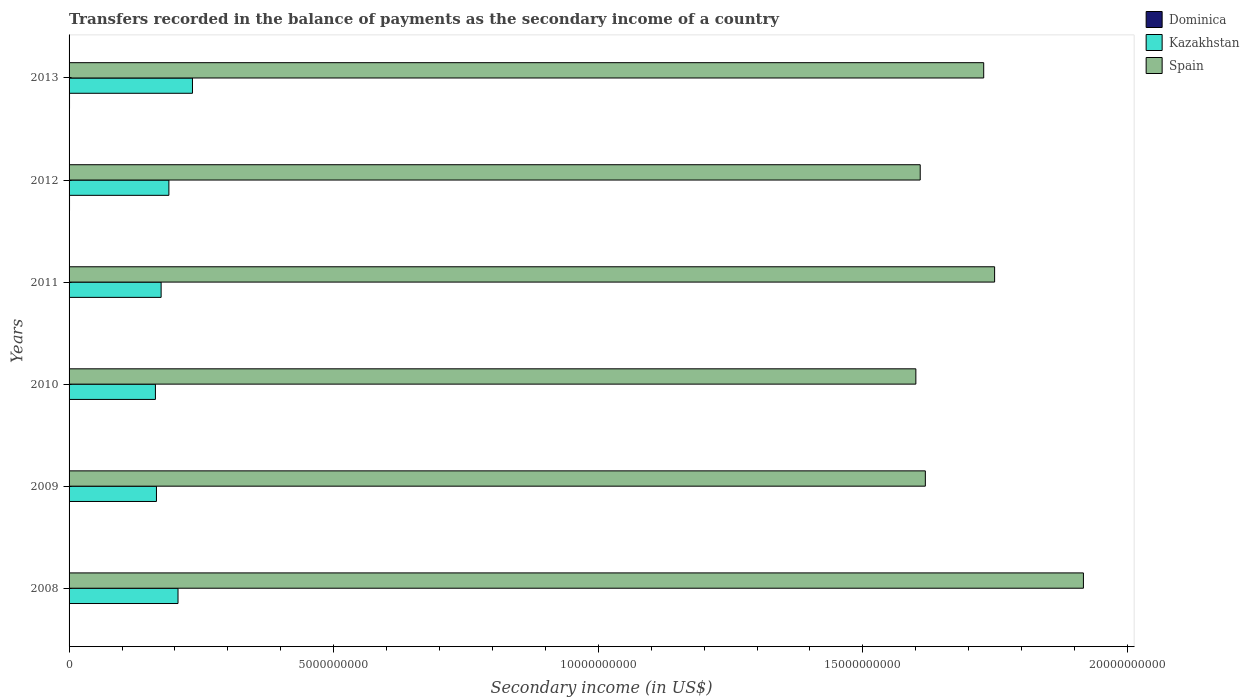How many different coloured bars are there?
Offer a very short reply. 3. What is the label of the 6th group of bars from the top?
Your answer should be compact. 2008. What is the secondary income of in Kazakhstan in 2008?
Ensure brevity in your answer.  2.06e+09. Across all years, what is the maximum secondary income of in Dominica?
Provide a short and direct response. 8.64e+06. Across all years, what is the minimum secondary income of in Kazakhstan?
Provide a short and direct response. 1.63e+09. What is the total secondary income of in Spain in the graph?
Offer a very short reply. 1.02e+11. What is the difference between the secondary income of in Dominica in 2011 and that in 2013?
Your answer should be compact. -2.50e+06. What is the difference between the secondary income of in Kazakhstan in 2010 and the secondary income of in Dominica in 2013?
Offer a very short reply. 1.62e+09. What is the average secondary income of in Spain per year?
Provide a succinct answer. 1.70e+1. In the year 2013, what is the difference between the secondary income of in Spain and secondary income of in Kazakhstan?
Give a very brief answer. 1.50e+1. In how many years, is the secondary income of in Dominica greater than 2000000000 US$?
Provide a succinct answer. 0. What is the ratio of the secondary income of in Spain in 2008 to that in 2009?
Ensure brevity in your answer.  1.18. What is the difference between the highest and the second highest secondary income of in Kazakhstan?
Make the answer very short. 2.73e+08. What is the difference between the highest and the lowest secondary income of in Dominica?
Ensure brevity in your answer.  3.87e+06. In how many years, is the secondary income of in Dominica greater than the average secondary income of in Dominica taken over all years?
Ensure brevity in your answer.  2. What does the 3rd bar from the top in 2013 represents?
Provide a succinct answer. Dominica. What does the 3rd bar from the bottom in 2012 represents?
Your response must be concise. Spain. How many bars are there?
Your answer should be compact. 18. Are the values on the major ticks of X-axis written in scientific E-notation?
Your response must be concise. No. Does the graph contain any zero values?
Offer a very short reply. No. Where does the legend appear in the graph?
Provide a succinct answer. Top right. How many legend labels are there?
Provide a short and direct response. 3. How are the legend labels stacked?
Your answer should be very brief. Vertical. What is the title of the graph?
Offer a very short reply. Transfers recorded in the balance of payments as the secondary income of a country. Does "Serbia" appear as one of the legend labels in the graph?
Your answer should be very brief. No. What is the label or title of the X-axis?
Keep it short and to the point. Secondary income (in US$). What is the Secondary income (in US$) in Dominica in 2008?
Keep it short and to the point. 4.96e+06. What is the Secondary income (in US$) of Kazakhstan in 2008?
Your answer should be very brief. 2.06e+09. What is the Secondary income (in US$) of Spain in 2008?
Give a very brief answer. 1.92e+1. What is the Secondary income (in US$) of Dominica in 2009?
Keep it short and to the point. 4.77e+06. What is the Secondary income (in US$) of Kazakhstan in 2009?
Ensure brevity in your answer.  1.65e+09. What is the Secondary income (in US$) in Spain in 2009?
Offer a terse response. 1.62e+1. What is the Secondary income (in US$) of Dominica in 2010?
Your answer should be compact. 4.85e+06. What is the Secondary income (in US$) in Kazakhstan in 2010?
Your response must be concise. 1.63e+09. What is the Secondary income (in US$) in Spain in 2010?
Offer a terse response. 1.60e+1. What is the Secondary income (in US$) in Dominica in 2011?
Your answer should be compact. 6.14e+06. What is the Secondary income (in US$) of Kazakhstan in 2011?
Provide a succinct answer. 1.74e+09. What is the Secondary income (in US$) of Spain in 2011?
Give a very brief answer. 1.75e+1. What is the Secondary income (in US$) in Dominica in 2012?
Give a very brief answer. 8.56e+06. What is the Secondary income (in US$) of Kazakhstan in 2012?
Ensure brevity in your answer.  1.89e+09. What is the Secondary income (in US$) of Spain in 2012?
Your answer should be compact. 1.61e+1. What is the Secondary income (in US$) in Dominica in 2013?
Provide a short and direct response. 8.64e+06. What is the Secondary income (in US$) in Kazakhstan in 2013?
Your answer should be very brief. 2.33e+09. What is the Secondary income (in US$) in Spain in 2013?
Provide a succinct answer. 1.73e+1. Across all years, what is the maximum Secondary income (in US$) in Dominica?
Provide a succinct answer. 8.64e+06. Across all years, what is the maximum Secondary income (in US$) of Kazakhstan?
Ensure brevity in your answer.  2.33e+09. Across all years, what is the maximum Secondary income (in US$) of Spain?
Your response must be concise. 1.92e+1. Across all years, what is the minimum Secondary income (in US$) of Dominica?
Offer a terse response. 4.77e+06. Across all years, what is the minimum Secondary income (in US$) in Kazakhstan?
Ensure brevity in your answer.  1.63e+09. Across all years, what is the minimum Secondary income (in US$) of Spain?
Offer a terse response. 1.60e+1. What is the total Secondary income (in US$) in Dominica in the graph?
Your answer should be compact. 3.79e+07. What is the total Secondary income (in US$) of Kazakhstan in the graph?
Your answer should be compact. 1.13e+1. What is the total Secondary income (in US$) of Spain in the graph?
Provide a short and direct response. 1.02e+11. What is the difference between the Secondary income (in US$) in Dominica in 2008 and that in 2009?
Ensure brevity in your answer.  1.88e+05. What is the difference between the Secondary income (in US$) of Kazakhstan in 2008 and that in 2009?
Keep it short and to the point. 4.07e+08. What is the difference between the Secondary income (in US$) of Spain in 2008 and that in 2009?
Your answer should be compact. 2.99e+09. What is the difference between the Secondary income (in US$) in Dominica in 2008 and that in 2010?
Ensure brevity in your answer.  1.09e+05. What is the difference between the Secondary income (in US$) of Kazakhstan in 2008 and that in 2010?
Ensure brevity in your answer.  4.27e+08. What is the difference between the Secondary income (in US$) of Spain in 2008 and that in 2010?
Make the answer very short. 3.17e+09. What is the difference between the Secondary income (in US$) in Dominica in 2008 and that in 2011?
Your answer should be very brief. -1.17e+06. What is the difference between the Secondary income (in US$) in Kazakhstan in 2008 and that in 2011?
Your answer should be very brief. 3.19e+08. What is the difference between the Secondary income (in US$) in Spain in 2008 and that in 2011?
Your answer should be compact. 1.68e+09. What is the difference between the Secondary income (in US$) in Dominica in 2008 and that in 2012?
Give a very brief answer. -3.59e+06. What is the difference between the Secondary income (in US$) in Kazakhstan in 2008 and that in 2012?
Your answer should be compact. 1.72e+08. What is the difference between the Secondary income (in US$) in Spain in 2008 and that in 2012?
Provide a succinct answer. 3.08e+09. What is the difference between the Secondary income (in US$) in Dominica in 2008 and that in 2013?
Offer a terse response. -3.68e+06. What is the difference between the Secondary income (in US$) in Kazakhstan in 2008 and that in 2013?
Offer a very short reply. -2.73e+08. What is the difference between the Secondary income (in US$) in Spain in 2008 and that in 2013?
Keep it short and to the point. 1.88e+09. What is the difference between the Secondary income (in US$) of Dominica in 2009 and that in 2010?
Your answer should be compact. -7.89e+04. What is the difference between the Secondary income (in US$) of Kazakhstan in 2009 and that in 2010?
Offer a terse response. 1.94e+07. What is the difference between the Secondary income (in US$) in Spain in 2009 and that in 2010?
Your response must be concise. 1.79e+08. What is the difference between the Secondary income (in US$) of Dominica in 2009 and that in 2011?
Give a very brief answer. -1.36e+06. What is the difference between the Secondary income (in US$) of Kazakhstan in 2009 and that in 2011?
Offer a very short reply. -8.83e+07. What is the difference between the Secondary income (in US$) of Spain in 2009 and that in 2011?
Offer a very short reply. -1.31e+09. What is the difference between the Secondary income (in US$) in Dominica in 2009 and that in 2012?
Ensure brevity in your answer.  -3.78e+06. What is the difference between the Secondary income (in US$) in Kazakhstan in 2009 and that in 2012?
Offer a very short reply. -2.35e+08. What is the difference between the Secondary income (in US$) in Spain in 2009 and that in 2012?
Provide a short and direct response. 9.67e+07. What is the difference between the Secondary income (in US$) in Dominica in 2009 and that in 2013?
Your answer should be compact. -3.87e+06. What is the difference between the Secondary income (in US$) in Kazakhstan in 2009 and that in 2013?
Provide a succinct answer. -6.80e+08. What is the difference between the Secondary income (in US$) of Spain in 2009 and that in 2013?
Make the answer very short. -1.10e+09. What is the difference between the Secondary income (in US$) of Dominica in 2010 and that in 2011?
Provide a short and direct response. -1.28e+06. What is the difference between the Secondary income (in US$) of Kazakhstan in 2010 and that in 2011?
Your response must be concise. -1.08e+08. What is the difference between the Secondary income (in US$) in Spain in 2010 and that in 2011?
Make the answer very short. -1.49e+09. What is the difference between the Secondary income (in US$) of Dominica in 2010 and that in 2012?
Your answer should be very brief. -3.70e+06. What is the difference between the Secondary income (in US$) in Kazakhstan in 2010 and that in 2012?
Give a very brief answer. -2.54e+08. What is the difference between the Secondary income (in US$) of Spain in 2010 and that in 2012?
Provide a succinct answer. -8.23e+07. What is the difference between the Secondary income (in US$) of Dominica in 2010 and that in 2013?
Provide a short and direct response. -3.79e+06. What is the difference between the Secondary income (in US$) in Kazakhstan in 2010 and that in 2013?
Keep it short and to the point. -7.00e+08. What is the difference between the Secondary income (in US$) of Spain in 2010 and that in 2013?
Keep it short and to the point. -1.28e+09. What is the difference between the Secondary income (in US$) in Dominica in 2011 and that in 2012?
Your answer should be very brief. -2.42e+06. What is the difference between the Secondary income (in US$) of Kazakhstan in 2011 and that in 2012?
Keep it short and to the point. -1.47e+08. What is the difference between the Secondary income (in US$) in Spain in 2011 and that in 2012?
Provide a succinct answer. 1.41e+09. What is the difference between the Secondary income (in US$) of Dominica in 2011 and that in 2013?
Your response must be concise. -2.50e+06. What is the difference between the Secondary income (in US$) in Kazakhstan in 2011 and that in 2013?
Your answer should be compact. -5.92e+08. What is the difference between the Secondary income (in US$) of Spain in 2011 and that in 2013?
Make the answer very short. 2.06e+08. What is the difference between the Secondary income (in US$) in Dominica in 2012 and that in 2013?
Provide a short and direct response. -8.50e+04. What is the difference between the Secondary income (in US$) in Kazakhstan in 2012 and that in 2013?
Keep it short and to the point. -4.45e+08. What is the difference between the Secondary income (in US$) of Spain in 2012 and that in 2013?
Make the answer very short. -1.20e+09. What is the difference between the Secondary income (in US$) in Dominica in 2008 and the Secondary income (in US$) in Kazakhstan in 2009?
Offer a very short reply. -1.65e+09. What is the difference between the Secondary income (in US$) of Dominica in 2008 and the Secondary income (in US$) of Spain in 2009?
Make the answer very short. -1.62e+1. What is the difference between the Secondary income (in US$) in Kazakhstan in 2008 and the Secondary income (in US$) in Spain in 2009?
Provide a short and direct response. -1.41e+1. What is the difference between the Secondary income (in US$) in Dominica in 2008 and the Secondary income (in US$) in Kazakhstan in 2010?
Your answer should be compact. -1.63e+09. What is the difference between the Secondary income (in US$) of Dominica in 2008 and the Secondary income (in US$) of Spain in 2010?
Your answer should be compact. -1.60e+1. What is the difference between the Secondary income (in US$) in Kazakhstan in 2008 and the Secondary income (in US$) in Spain in 2010?
Your answer should be compact. -1.39e+1. What is the difference between the Secondary income (in US$) of Dominica in 2008 and the Secondary income (in US$) of Kazakhstan in 2011?
Your answer should be very brief. -1.73e+09. What is the difference between the Secondary income (in US$) of Dominica in 2008 and the Secondary income (in US$) of Spain in 2011?
Provide a succinct answer. -1.75e+1. What is the difference between the Secondary income (in US$) in Kazakhstan in 2008 and the Secondary income (in US$) in Spain in 2011?
Your answer should be compact. -1.54e+1. What is the difference between the Secondary income (in US$) of Dominica in 2008 and the Secondary income (in US$) of Kazakhstan in 2012?
Ensure brevity in your answer.  -1.88e+09. What is the difference between the Secondary income (in US$) of Dominica in 2008 and the Secondary income (in US$) of Spain in 2012?
Provide a short and direct response. -1.61e+1. What is the difference between the Secondary income (in US$) in Kazakhstan in 2008 and the Secondary income (in US$) in Spain in 2012?
Provide a succinct answer. -1.40e+1. What is the difference between the Secondary income (in US$) of Dominica in 2008 and the Secondary income (in US$) of Kazakhstan in 2013?
Provide a short and direct response. -2.33e+09. What is the difference between the Secondary income (in US$) of Dominica in 2008 and the Secondary income (in US$) of Spain in 2013?
Make the answer very short. -1.73e+1. What is the difference between the Secondary income (in US$) in Kazakhstan in 2008 and the Secondary income (in US$) in Spain in 2013?
Provide a succinct answer. -1.52e+1. What is the difference between the Secondary income (in US$) in Dominica in 2009 and the Secondary income (in US$) in Kazakhstan in 2010?
Keep it short and to the point. -1.63e+09. What is the difference between the Secondary income (in US$) in Dominica in 2009 and the Secondary income (in US$) in Spain in 2010?
Make the answer very short. -1.60e+1. What is the difference between the Secondary income (in US$) of Kazakhstan in 2009 and the Secondary income (in US$) of Spain in 2010?
Make the answer very short. -1.43e+1. What is the difference between the Secondary income (in US$) of Dominica in 2009 and the Secondary income (in US$) of Kazakhstan in 2011?
Your answer should be very brief. -1.73e+09. What is the difference between the Secondary income (in US$) of Dominica in 2009 and the Secondary income (in US$) of Spain in 2011?
Make the answer very short. -1.75e+1. What is the difference between the Secondary income (in US$) in Kazakhstan in 2009 and the Secondary income (in US$) in Spain in 2011?
Provide a short and direct response. -1.58e+1. What is the difference between the Secondary income (in US$) in Dominica in 2009 and the Secondary income (in US$) in Kazakhstan in 2012?
Make the answer very short. -1.88e+09. What is the difference between the Secondary income (in US$) of Dominica in 2009 and the Secondary income (in US$) of Spain in 2012?
Ensure brevity in your answer.  -1.61e+1. What is the difference between the Secondary income (in US$) in Kazakhstan in 2009 and the Secondary income (in US$) in Spain in 2012?
Ensure brevity in your answer.  -1.44e+1. What is the difference between the Secondary income (in US$) of Dominica in 2009 and the Secondary income (in US$) of Kazakhstan in 2013?
Offer a terse response. -2.33e+09. What is the difference between the Secondary income (in US$) of Dominica in 2009 and the Secondary income (in US$) of Spain in 2013?
Keep it short and to the point. -1.73e+1. What is the difference between the Secondary income (in US$) in Kazakhstan in 2009 and the Secondary income (in US$) in Spain in 2013?
Keep it short and to the point. -1.56e+1. What is the difference between the Secondary income (in US$) in Dominica in 2010 and the Secondary income (in US$) in Kazakhstan in 2011?
Make the answer very short. -1.73e+09. What is the difference between the Secondary income (in US$) of Dominica in 2010 and the Secondary income (in US$) of Spain in 2011?
Provide a short and direct response. -1.75e+1. What is the difference between the Secondary income (in US$) of Kazakhstan in 2010 and the Secondary income (in US$) of Spain in 2011?
Provide a short and direct response. -1.59e+1. What is the difference between the Secondary income (in US$) of Dominica in 2010 and the Secondary income (in US$) of Kazakhstan in 2012?
Give a very brief answer. -1.88e+09. What is the difference between the Secondary income (in US$) in Dominica in 2010 and the Secondary income (in US$) in Spain in 2012?
Provide a short and direct response. -1.61e+1. What is the difference between the Secondary income (in US$) in Kazakhstan in 2010 and the Secondary income (in US$) in Spain in 2012?
Provide a short and direct response. -1.45e+1. What is the difference between the Secondary income (in US$) in Dominica in 2010 and the Secondary income (in US$) in Kazakhstan in 2013?
Your answer should be compact. -2.33e+09. What is the difference between the Secondary income (in US$) in Dominica in 2010 and the Secondary income (in US$) in Spain in 2013?
Ensure brevity in your answer.  -1.73e+1. What is the difference between the Secondary income (in US$) of Kazakhstan in 2010 and the Secondary income (in US$) of Spain in 2013?
Make the answer very short. -1.57e+1. What is the difference between the Secondary income (in US$) in Dominica in 2011 and the Secondary income (in US$) in Kazakhstan in 2012?
Your answer should be very brief. -1.88e+09. What is the difference between the Secondary income (in US$) in Dominica in 2011 and the Secondary income (in US$) in Spain in 2012?
Ensure brevity in your answer.  -1.61e+1. What is the difference between the Secondary income (in US$) in Kazakhstan in 2011 and the Secondary income (in US$) in Spain in 2012?
Your response must be concise. -1.43e+1. What is the difference between the Secondary income (in US$) of Dominica in 2011 and the Secondary income (in US$) of Kazakhstan in 2013?
Provide a succinct answer. -2.33e+09. What is the difference between the Secondary income (in US$) in Dominica in 2011 and the Secondary income (in US$) in Spain in 2013?
Your answer should be compact. -1.73e+1. What is the difference between the Secondary income (in US$) in Kazakhstan in 2011 and the Secondary income (in US$) in Spain in 2013?
Ensure brevity in your answer.  -1.55e+1. What is the difference between the Secondary income (in US$) in Dominica in 2012 and the Secondary income (in US$) in Kazakhstan in 2013?
Your response must be concise. -2.32e+09. What is the difference between the Secondary income (in US$) of Dominica in 2012 and the Secondary income (in US$) of Spain in 2013?
Offer a very short reply. -1.73e+1. What is the difference between the Secondary income (in US$) in Kazakhstan in 2012 and the Secondary income (in US$) in Spain in 2013?
Your answer should be compact. -1.54e+1. What is the average Secondary income (in US$) of Dominica per year?
Provide a short and direct response. 6.32e+06. What is the average Secondary income (in US$) of Kazakhstan per year?
Offer a very short reply. 1.88e+09. What is the average Secondary income (in US$) of Spain per year?
Make the answer very short. 1.70e+1. In the year 2008, what is the difference between the Secondary income (in US$) of Dominica and Secondary income (in US$) of Kazakhstan?
Provide a succinct answer. -2.05e+09. In the year 2008, what is the difference between the Secondary income (in US$) of Dominica and Secondary income (in US$) of Spain?
Your answer should be compact. -1.92e+1. In the year 2008, what is the difference between the Secondary income (in US$) in Kazakhstan and Secondary income (in US$) in Spain?
Give a very brief answer. -1.71e+1. In the year 2009, what is the difference between the Secondary income (in US$) of Dominica and Secondary income (in US$) of Kazakhstan?
Your response must be concise. -1.65e+09. In the year 2009, what is the difference between the Secondary income (in US$) in Dominica and Secondary income (in US$) in Spain?
Provide a succinct answer. -1.62e+1. In the year 2009, what is the difference between the Secondary income (in US$) of Kazakhstan and Secondary income (in US$) of Spain?
Provide a short and direct response. -1.45e+1. In the year 2010, what is the difference between the Secondary income (in US$) in Dominica and Secondary income (in US$) in Kazakhstan?
Your response must be concise. -1.63e+09. In the year 2010, what is the difference between the Secondary income (in US$) in Dominica and Secondary income (in US$) in Spain?
Keep it short and to the point. -1.60e+1. In the year 2010, what is the difference between the Secondary income (in US$) in Kazakhstan and Secondary income (in US$) in Spain?
Provide a short and direct response. -1.44e+1. In the year 2011, what is the difference between the Secondary income (in US$) of Dominica and Secondary income (in US$) of Kazakhstan?
Provide a short and direct response. -1.73e+09. In the year 2011, what is the difference between the Secondary income (in US$) in Dominica and Secondary income (in US$) in Spain?
Keep it short and to the point. -1.75e+1. In the year 2011, what is the difference between the Secondary income (in US$) in Kazakhstan and Secondary income (in US$) in Spain?
Ensure brevity in your answer.  -1.57e+1. In the year 2012, what is the difference between the Secondary income (in US$) of Dominica and Secondary income (in US$) of Kazakhstan?
Offer a very short reply. -1.88e+09. In the year 2012, what is the difference between the Secondary income (in US$) in Dominica and Secondary income (in US$) in Spain?
Your answer should be very brief. -1.61e+1. In the year 2012, what is the difference between the Secondary income (in US$) of Kazakhstan and Secondary income (in US$) of Spain?
Offer a very short reply. -1.42e+1. In the year 2013, what is the difference between the Secondary income (in US$) of Dominica and Secondary income (in US$) of Kazakhstan?
Offer a very short reply. -2.32e+09. In the year 2013, what is the difference between the Secondary income (in US$) of Dominica and Secondary income (in US$) of Spain?
Your answer should be very brief. -1.73e+1. In the year 2013, what is the difference between the Secondary income (in US$) of Kazakhstan and Secondary income (in US$) of Spain?
Provide a short and direct response. -1.50e+1. What is the ratio of the Secondary income (in US$) of Dominica in 2008 to that in 2009?
Your answer should be compact. 1.04. What is the ratio of the Secondary income (in US$) of Kazakhstan in 2008 to that in 2009?
Your answer should be very brief. 1.25. What is the ratio of the Secondary income (in US$) in Spain in 2008 to that in 2009?
Offer a very short reply. 1.18. What is the ratio of the Secondary income (in US$) of Dominica in 2008 to that in 2010?
Make the answer very short. 1.02. What is the ratio of the Secondary income (in US$) of Kazakhstan in 2008 to that in 2010?
Provide a succinct answer. 1.26. What is the ratio of the Secondary income (in US$) of Spain in 2008 to that in 2010?
Ensure brevity in your answer.  1.2. What is the ratio of the Secondary income (in US$) in Dominica in 2008 to that in 2011?
Make the answer very short. 0.81. What is the ratio of the Secondary income (in US$) of Kazakhstan in 2008 to that in 2011?
Ensure brevity in your answer.  1.18. What is the ratio of the Secondary income (in US$) of Spain in 2008 to that in 2011?
Keep it short and to the point. 1.1. What is the ratio of the Secondary income (in US$) in Dominica in 2008 to that in 2012?
Provide a short and direct response. 0.58. What is the ratio of the Secondary income (in US$) in Kazakhstan in 2008 to that in 2012?
Provide a short and direct response. 1.09. What is the ratio of the Secondary income (in US$) in Spain in 2008 to that in 2012?
Make the answer very short. 1.19. What is the ratio of the Secondary income (in US$) of Dominica in 2008 to that in 2013?
Your answer should be compact. 0.57. What is the ratio of the Secondary income (in US$) of Kazakhstan in 2008 to that in 2013?
Provide a short and direct response. 0.88. What is the ratio of the Secondary income (in US$) in Spain in 2008 to that in 2013?
Your answer should be very brief. 1.11. What is the ratio of the Secondary income (in US$) of Dominica in 2009 to that in 2010?
Keep it short and to the point. 0.98. What is the ratio of the Secondary income (in US$) of Kazakhstan in 2009 to that in 2010?
Offer a very short reply. 1.01. What is the ratio of the Secondary income (in US$) in Spain in 2009 to that in 2010?
Ensure brevity in your answer.  1.01. What is the ratio of the Secondary income (in US$) in Dominica in 2009 to that in 2011?
Keep it short and to the point. 0.78. What is the ratio of the Secondary income (in US$) in Kazakhstan in 2009 to that in 2011?
Provide a short and direct response. 0.95. What is the ratio of the Secondary income (in US$) of Spain in 2009 to that in 2011?
Offer a terse response. 0.93. What is the ratio of the Secondary income (in US$) in Dominica in 2009 to that in 2012?
Keep it short and to the point. 0.56. What is the ratio of the Secondary income (in US$) of Kazakhstan in 2009 to that in 2012?
Keep it short and to the point. 0.88. What is the ratio of the Secondary income (in US$) in Spain in 2009 to that in 2012?
Make the answer very short. 1.01. What is the ratio of the Secondary income (in US$) of Dominica in 2009 to that in 2013?
Your answer should be very brief. 0.55. What is the ratio of the Secondary income (in US$) in Kazakhstan in 2009 to that in 2013?
Make the answer very short. 0.71. What is the ratio of the Secondary income (in US$) in Spain in 2009 to that in 2013?
Keep it short and to the point. 0.94. What is the ratio of the Secondary income (in US$) of Dominica in 2010 to that in 2011?
Provide a succinct answer. 0.79. What is the ratio of the Secondary income (in US$) in Kazakhstan in 2010 to that in 2011?
Offer a very short reply. 0.94. What is the ratio of the Secondary income (in US$) of Spain in 2010 to that in 2011?
Your response must be concise. 0.91. What is the ratio of the Secondary income (in US$) in Dominica in 2010 to that in 2012?
Your answer should be compact. 0.57. What is the ratio of the Secondary income (in US$) in Kazakhstan in 2010 to that in 2012?
Ensure brevity in your answer.  0.87. What is the ratio of the Secondary income (in US$) of Dominica in 2010 to that in 2013?
Provide a succinct answer. 0.56. What is the ratio of the Secondary income (in US$) of Kazakhstan in 2010 to that in 2013?
Offer a very short reply. 0.7. What is the ratio of the Secondary income (in US$) of Spain in 2010 to that in 2013?
Provide a succinct answer. 0.93. What is the ratio of the Secondary income (in US$) in Dominica in 2011 to that in 2012?
Provide a succinct answer. 0.72. What is the ratio of the Secondary income (in US$) of Kazakhstan in 2011 to that in 2012?
Offer a very short reply. 0.92. What is the ratio of the Secondary income (in US$) of Spain in 2011 to that in 2012?
Ensure brevity in your answer.  1.09. What is the ratio of the Secondary income (in US$) in Dominica in 2011 to that in 2013?
Your answer should be compact. 0.71. What is the ratio of the Secondary income (in US$) of Kazakhstan in 2011 to that in 2013?
Keep it short and to the point. 0.75. What is the ratio of the Secondary income (in US$) of Spain in 2011 to that in 2013?
Ensure brevity in your answer.  1.01. What is the ratio of the Secondary income (in US$) of Dominica in 2012 to that in 2013?
Your response must be concise. 0.99. What is the ratio of the Secondary income (in US$) of Kazakhstan in 2012 to that in 2013?
Make the answer very short. 0.81. What is the ratio of the Secondary income (in US$) in Spain in 2012 to that in 2013?
Your answer should be compact. 0.93. What is the difference between the highest and the second highest Secondary income (in US$) in Dominica?
Give a very brief answer. 8.50e+04. What is the difference between the highest and the second highest Secondary income (in US$) of Kazakhstan?
Make the answer very short. 2.73e+08. What is the difference between the highest and the second highest Secondary income (in US$) in Spain?
Provide a short and direct response. 1.68e+09. What is the difference between the highest and the lowest Secondary income (in US$) in Dominica?
Your answer should be very brief. 3.87e+06. What is the difference between the highest and the lowest Secondary income (in US$) of Kazakhstan?
Your answer should be very brief. 7.00e+08. What is the difference between the highest and the lowest Secondary income (in US$) in Spain?
Offer a very short reply. 3.17e+09. 